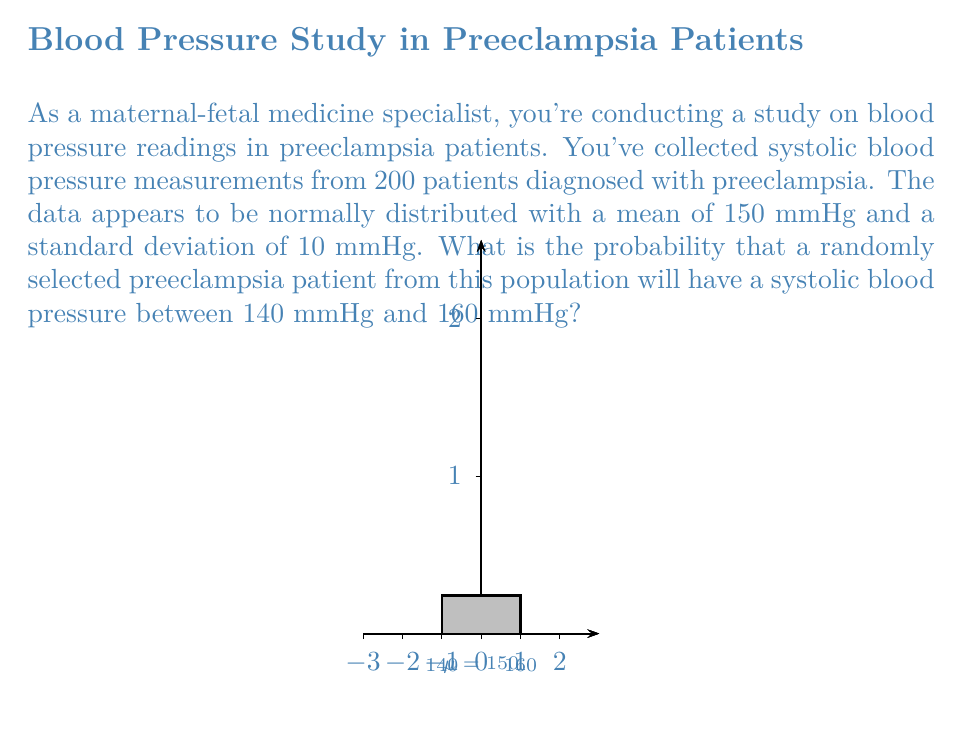Teach me how to tackle this problem. To solve this problem, we'll use the properties of the normal distribution and the z-score formula. Here's a step-by-step approach:

1) We're given that the blood pressure readings are normally distributed with:
   Mean (μ) = 150 mmHg
   Standard deviation (σ) = 10 mmHg

2) We need to find the probability of a blood pressure reading between 140 and 160 mmHg.

3) First, we need to standardize these values using the z-score formula:
   $$z = \frac{x - μ}{σ}$$

4) For the lower bound (140 mmHg):
   $$z_1 = \frac{140 - 150}{10} = -1$$

5) For the upper bound (160 mmHg):
   $$z_2 = \frac{160 - 150}{10} = 1$$

6) Now, we need to find the area under the standard normal curve between z = -1 and z = 1.

7) This can be done by finding the area from the center to z = 1 and doubling it (due to symmetry of the normal distribution).

8) Using a standard normal table or calculator, we find:
   P(0 < Z < 1) ≈ 0.3413

9) The total area (probability) is:
   P(-1 < Z < 1) = 2 * 0.3413 = 0.6826

Therefore, the probability that a randomly selected preeclampsia patient will have a systolic blood pressure between 140 mmHg and 160 mmHg is approximately 0.6826 or 68.26%.
Answer: 0.6826 or 68.26% 